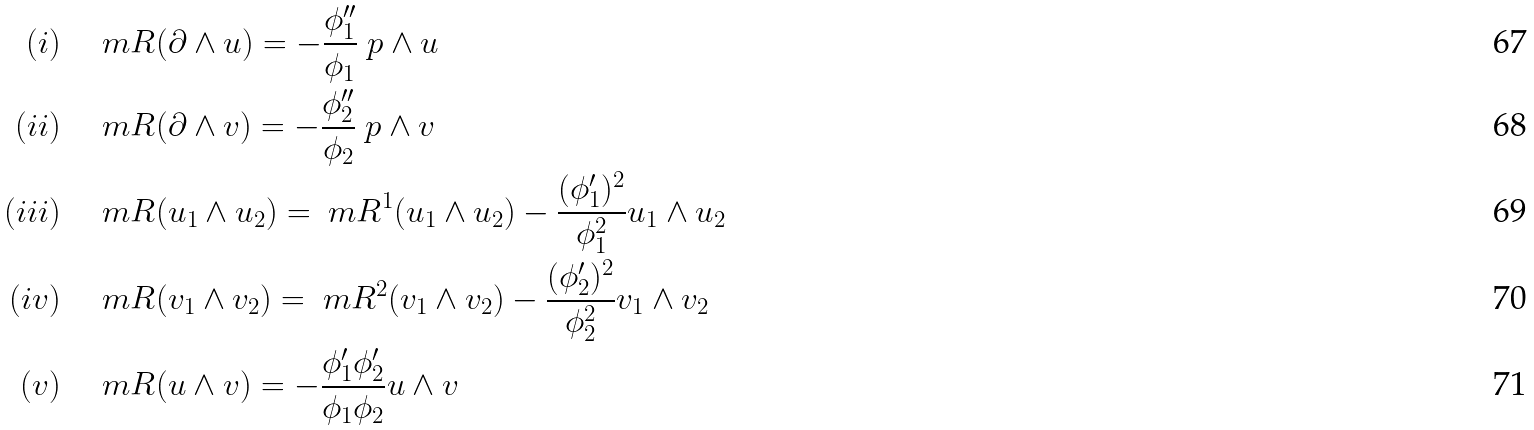<formula> <loc_0><loc_0><loc_500><loc_500>( i ) & \quad \ m R ( \partial \wedge u ) = - \frac { \phi _ { 1 } ^ { \prime \prime } } { \phi _ { 1 } } \ p \wedge u \\ ( i i ) & \quad \ m R ( \partial \wedge v ) = - \frac { \phi _ { 2 } ^ { \prime \prime } } { \phi _ { 2 } } \ p \wedge v \\ ( i i i ) & \quad \ m R ( u _ { 1 } \wedge u _ { 2 } ) = \ m R ^ { 1 } ( u _ { 1 } \wedge u _ { 2 } ) - \frac { ( \phi _ { 1 } ^ { \prime } ) ^ { 2 } } { \phi _ { 1 } ^ { 2 } } u _ { 1 } \wedge u _ { 2 } \\ ( i v ) & \quad \ m R ( v _ { 1 } \wedge v _ { 2 } ) = \ m R ^ { 2 } ( v _ { 1 } \wedge v _ { 2 } ) - \frac { ( \phi _ { 2 } ^ { \prime } ) ^ { 2 } } { \phi _ { 2 } ^ { 2 } } v _ { 1 } \wedge v _ { 2 } \\ ( v ) & \quad \ m R ( u \wedge v ) = - \frac { \phi _ { 1 } ^ { \prime } \phi _ { 2 } ^ { \prime } } { \phi _ { 1 } \phi _ { 2 } } u \wedge v</formula> 